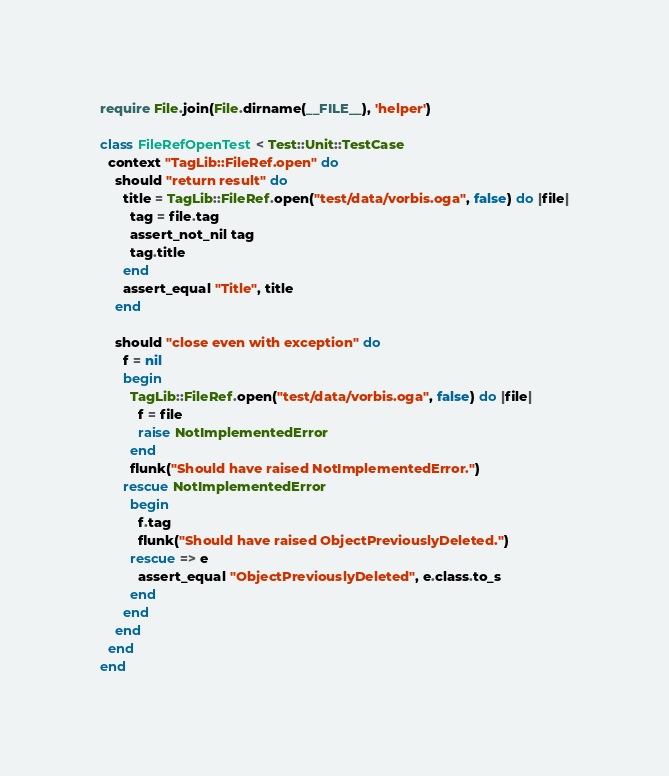<code> <loc_0><loc_0><loc_500><loc_500><_Ruby_>require File.join(File.dirname(__FILE__), 'helper')

class FileRefOpenTest < Test::Unit::TestCase
  context "TagLib::FileRef.open" do
    should "return result" do
      title = TagLib::FileRef.open("test/data/vorbis.oga", false) do |file|
        tag = file.tag
        assert_not_nil tag
        tag.title
      end
      assert_equal "Title", title
    end

    should "close even with exception" do
      f = nil
      begin
        TagLib::FileRef.open("test/data/vorbis.oga", false) do |file|
          f = file
          raise NotImplementedError
        end
        flunk("Should have raised NotImplementedError.")
      rescue NotImplementedError
        begin
          f.tag
          flunk("Should have raised ObjectPreviouslyDeleted.")
        rescue => e
          assert_equal "ObjectPreviouslyDeleted", e.class.to_s
        end
      end
    end
  end
end
</code> 